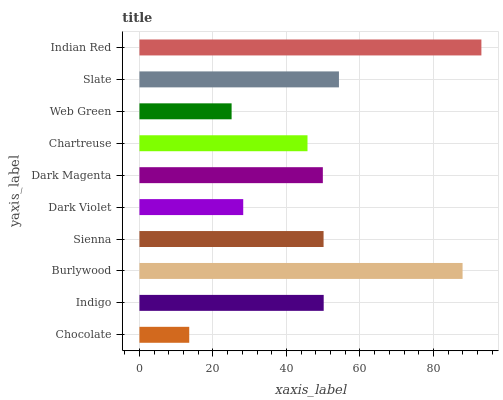Is Chocolate the minimum?
Answer yes or no. Yes. Is Indian Red the maximum?
Answer yes or no. Yes. Is Indigo the minimum?
Answer yes or no. No. Is Indigo the maximum?
Answer yes or no. No. Is Indigo greater than Chocolate?
Answer yes or no. Yes. Is Chocolate less than Indigo?
Answer yes or no. Yes. Is Chocolate greater than Indigo?
Answer yes or no. No. Is Indigo less than Chocolate?
Answer yes or no. No. Is Sienna the high median?
Answer yes or no. Yes. Is Dark Magenta the low median?
Answer yes or no. Yes. Is Indian Red the high median?
Answer yes or no. No. Is Indian Red the low median?
Answer yes or no. No. 